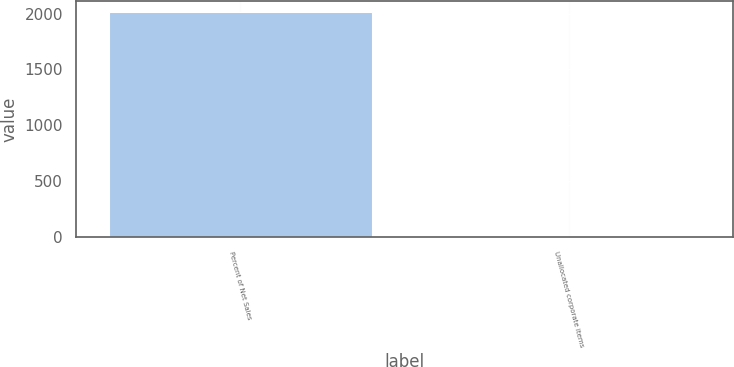Convert chart to OTSL. <chart><loc_0><loc_0><loc_500><loc_500><bar_chart><fcel>Percent of Net Sales<fcel>Unallocated corporate items<nl><fcel>2015<fcel>2.3<nl></chart> 